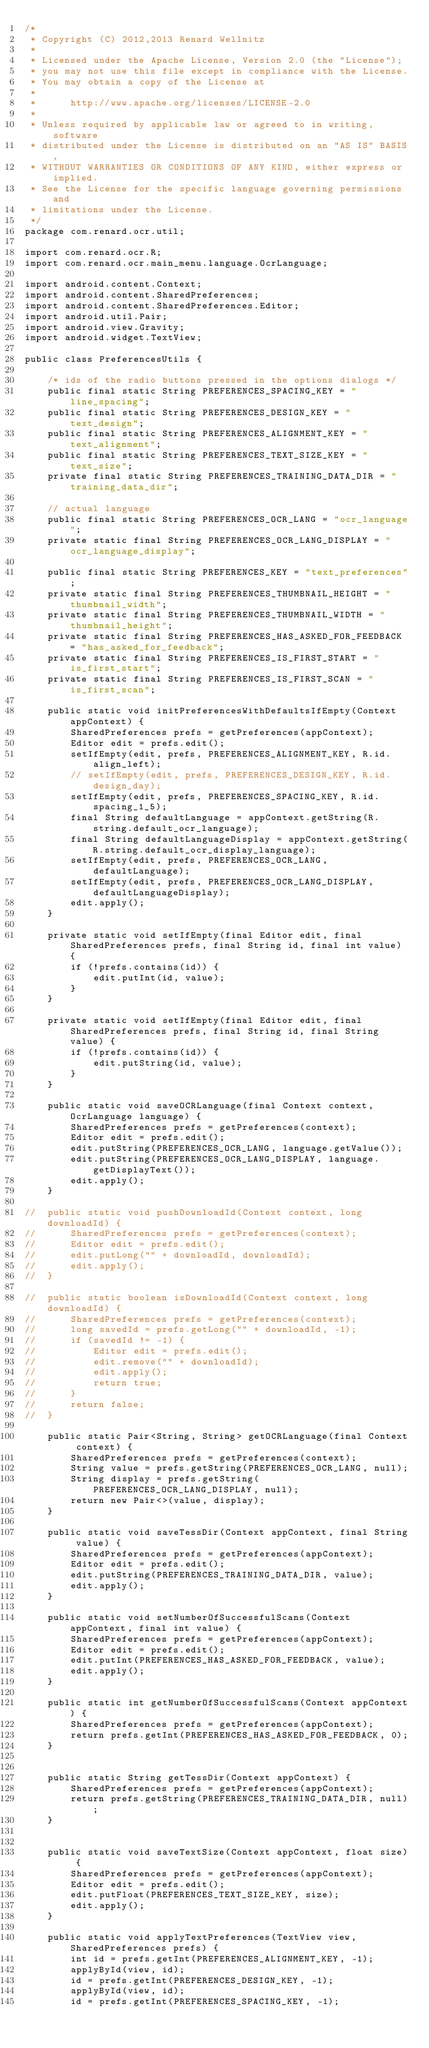Convert code to text. <code><loc_0><loc_0><loc_500><loc_500><_Java_>/*
 * Copyright (C) 2012,2013 Renard Wellnitz
 *
 * Licensed under the Apache License, Version 2.0 (the "License");
 * you may not use this file except in compliance with the License.
 * You may obtain a copy of the License at
 *
 *      http://www.apache.org/licenses/LICENSE-2.0
 *
 * Unless required by applicable law or agreed to in writing, software
 * distributed under the License is distributed on an "AS IS" BASIS,
 * WITHOUT WARRANTIES OR CONDITIONS OF ANY KIND, either express or implied.
 * See the License for the specific language governing permissions and
 * limitations under the License.
 */
package com.renard.ocr.util;

import com.renard.ocr.R;
import com.renard.ocr.main_menu.language.OcrLanguage;

import android.content.Context;
import android.content.SharedPreferences;
import android.content.SharedPreferences.Editor;
import android.util.Pair;
import android.view.Gravity;
import android.widget.TextView;

public class PreferencesUtils {

    /* ids of the radio buttons pressed in the options dialogs */
    public final static String PREFERENCES_SPACING_KEY = "line_spacing";
    public final static String PREFERENCES_DESIGN_KEY = "text_design";
    public final static String PREFERENCES_ALIGNMENT_KEY = "text_alignment";
    public final static String PREFERENCES_TEXT_SIZE_KEY = "text_size";
    private final static String PREFERENCES_TRAINING_DATA_DIR = "training_data_dir";

    // actual language
    public final static String PREFERENCES_OCR_LANG = "ocr_language";
    private static final String PREFERENCES_OCR_LANG_DISPLAY = "ocr_language_display";

    public final static String PREFERENCES_KEY = "text_preferences";
    private static final String PREFERENCES_THUMBNAIL_HEIGHT = "thumbnail_width";
    private static final String PREFERENCES_THUMBNAIL_WIDTH = "thumbnail_height";
    private static final String PREFERENCES_HAS_ASKED_FOR_FEEDBACK = "has_asked_for_feedback";
    private static final String PREFERENCES_IS_FIRST_START = "is_first_start";
    private static final String PREFERENCES_IS_FIRST_SCAN = "is_first_scan";

    public static void initPreferencesWithDefaultsIfEmpty(Context appContext) {
        SharedPreferences prefs = getPreferences(appContext);
        Editor edit = prefs.edit();
        setIfEmpty(edit, prefs, PREFERENCES_ALIGNMENT_KEY, R.id.align_left);
        // setIfEmpty(edit, prefs, PREFERENCES_DESIGN_KEY, R.id.design_day);
        setIfEmpty(edit, prefs, PREFERENCES_SPACING_KEY, R.id.spacing_1_5);
        final String defaultLanguage = appContext.getString(R.string.default_ocr_language);
        final String defaultLanguageDisplay = appContext.getString(R.string.default_ocr_display_language);
        setIfEmpty(edit, prefs, PREFERENCES_OCR_LANG, defaultLanguage);
        setIfEmpty(edit, prefs, PREFERENCES_OCR_LANG_DISPLAY, defaultLanguageDisplay);
        edit.apply();
    }

    private static void setIfEmpty(final Editor edit, final SharedPreferences prefs, final String id, final int value) {
        if (!prefs.contains(id)) {
            edit.putInt(id, value);
        }
    }

    private static void setIfEmpty(final Editor edit, final SharedPreferences prefs, final String id, final String value) {
        if (!prefs.contains(id)) {
            edit.putString(id, value);
        }
    }

    public static void saveOCRLanguage(final Context context, OcrLanguage language) {
        SharedPreferences prefs = getPreferences(context);
        Editor edit = prefs.edit();
        edit.putString(PREFERENCES_OCR_LANG, language.getValue());
        edit.putString(PREFERENCES_OCR_LANG_DISPLAY, language.getDisplayText());
        edit.apply();
    }

//	public static void pushDownloadId(Context context, long downloadId) {
//		SharedPreferences prefs = getPreferences(context);
//		Editor edit = prefs.edit();
//		edit.putLong("" + downloadId, downloadId);
//		edit.apply();
//	}

//	public static boolean isDownloadId(Context context, long downloadId) {
//		SharedPreferences prefs = getPreferences(context);
//		long savedId = prefs.getLong("" + downloadId, -1);
//		if (savedId != -1) {
//			Editor edit = prefs.edit();
//			edit.remove("" + downloadId);
//			edit.apply();
//			return true;
//		}
//		return false;
//	}

    public static Pair<String, String> getOCRLanguage(final Context context) {
        SharedPreferences prefs = getPreferences(context);
        String value = prefs.getString(PREFERENCES_OCR_LANG, null);
        String display = prefs.getString(PREFERENCES_OCR_LANG_DISPLAY, null);
        return new Pair<>(value, display);
    }

    public static void saveTessDir(Context appContext, final String value) {
        SharedPreferences prefs = getPreferences(appContext);
        Editor edit = prefs.edit();
        edit.putString(PREFERENCES_TRAINING_DATA_DIR, value);
        edit.apply();
    }

    public static void setNumberOfSuccessfulScans(Context appContext, final int value) {
        SharedPreferences prefs = getPreferences(appContext);
        Editor edit = prefs.edit();
        edit.putInt(PREFERENCES_HAS_ASKED_FOR_FEEDBACK, value);
        edit.apply();
    }

    public static int getNumberOfSuccessfulScans(Context appContext) {
        SharedPreferences prefs = getPreferences(appContext);
        return prefs.getInt(PREFERENCES_HAS_ASKED_FOR_FEEDBACK, 0);
    }


    public static String getTessDir(Context appContext) {
        SharedPreferences prefs = getPreferences(appContext);
        return prefs.getString(PREFERENCES_TRAINING_DATA_DIR, null);
    }


    public static void saveTextSize(Context appContext, float size) {
        SharedPreferences prefs = getPreferences(appContext);
        Editor edit = prefs.edit();
        edit.putFloat(PREFERENCES_TEXT_SIZE_KEY, size);
        edit.apply();
    }

    public static void applyTextPreferences(TextView view, SharedPreferences prefs) {
        int id = prefs.getInt(PREFERENCES_ALIGNMENT_KEY, -1);
        applyById(view, id);
        id = prefs.getInt(PREFERENCES_DESIGN_KEY, -1);
        applyById(view, id);
        id = prefs.getInt(PREFERENCES_SPACING_KEY, -1);</code> 